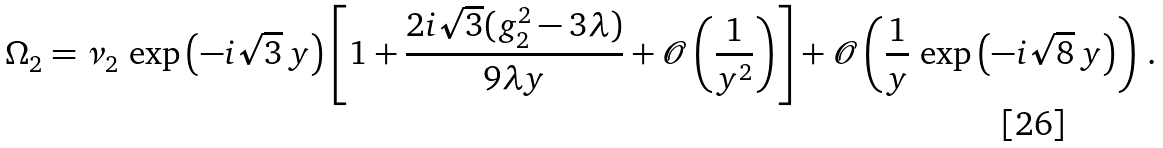Convert formula to latex. <formula><loc_0><loc_0><loc_500><loc_500>\Omega _ { 2 } = \nu _ { 2 } \, \exp \left ( - i \sqrt { 3 } \, y \right ) \left [ 1 + \frac { 2 i \sqrt { 3 } ( g _ { 2 } ^ { 2 } - 3 \lambda ) } { 9 \lambda y } + \mathcal { O } \left ( \frac { 1 } { y ^ { 2 } } \right ) \right ] + \mathcal { O } \left ( \frac { 1 } { y } \, \exp \left ( - i \sqrt { 8 } \, y \right ) \right ) \, .</formula> 